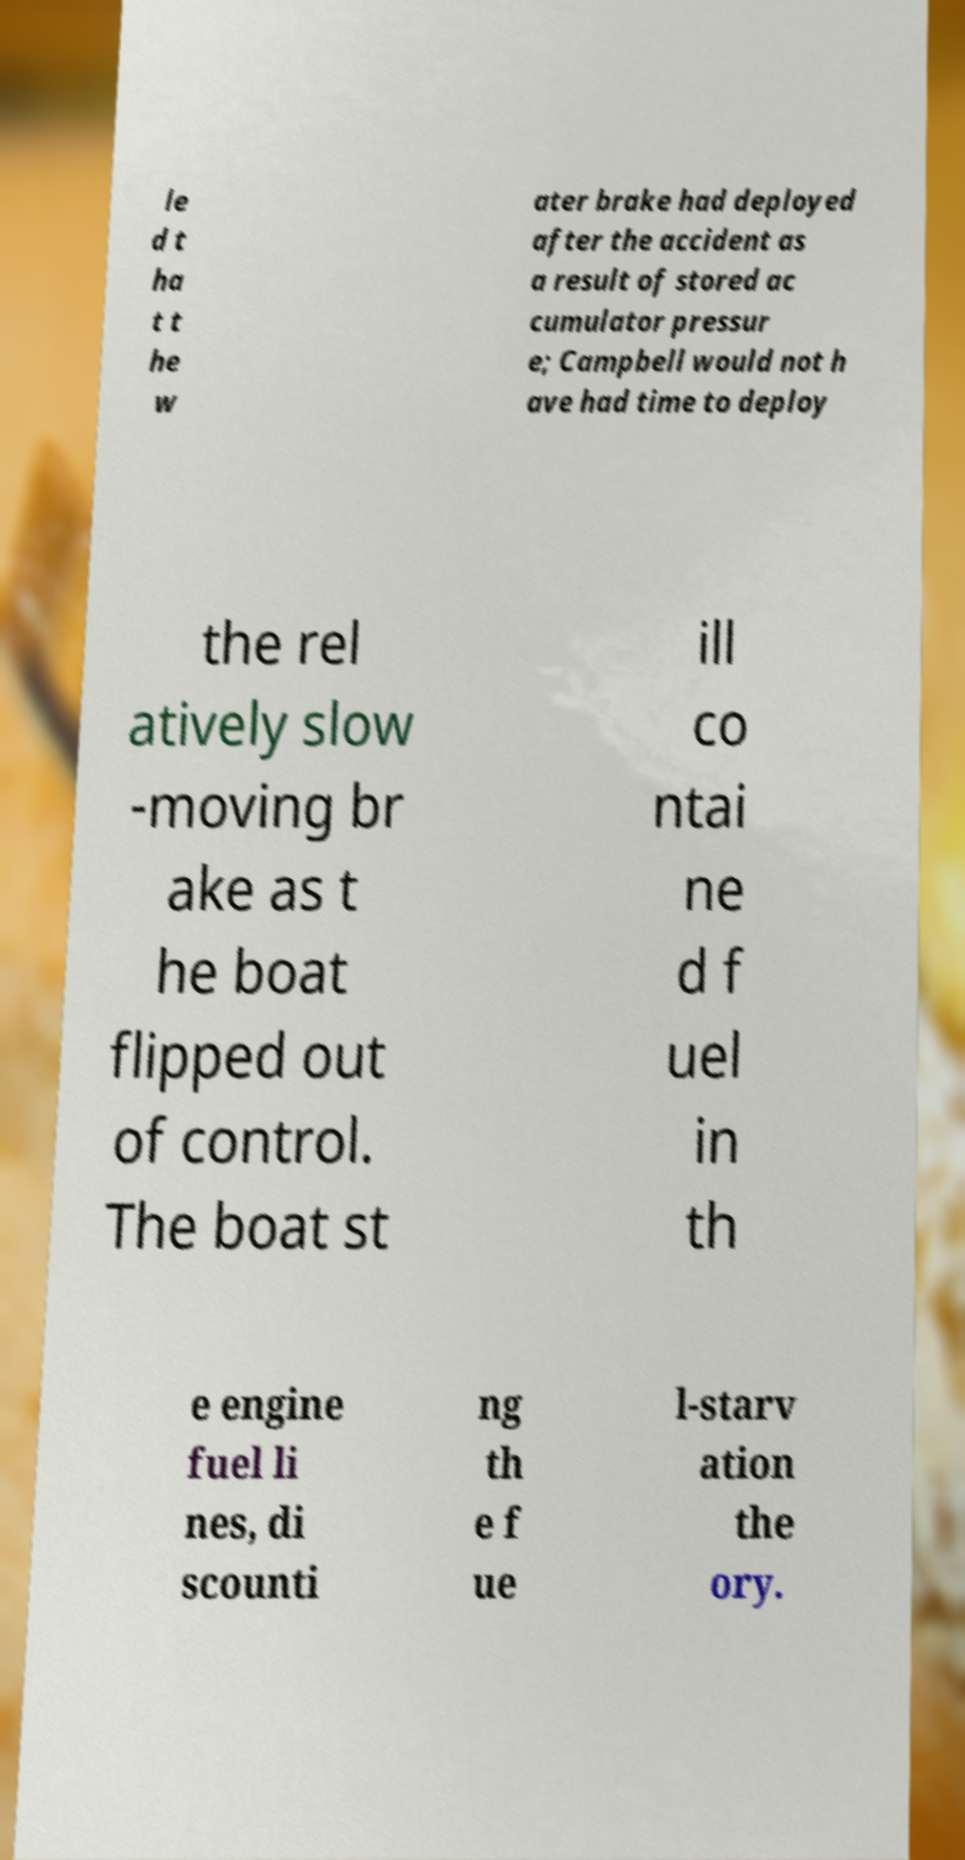There's text embedded in this image that I need extracted. Can you transcribe it verbatim? le d t ha t t he w ater brake had deployed after the accident as a result of stored ac cumulator pressur e; Campbell would not h ave had time to deploy the rel atively slow -moving br ake as t he boat flipped out of control. The boat st ill co ntai ne d f uel in th e engine fuel li nes, di scounti ng th e f ue l-starv ation the ory. 